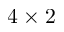<formula> <loc_0><loc_0><loc_500><loc_500>4 \times 2</formula> 